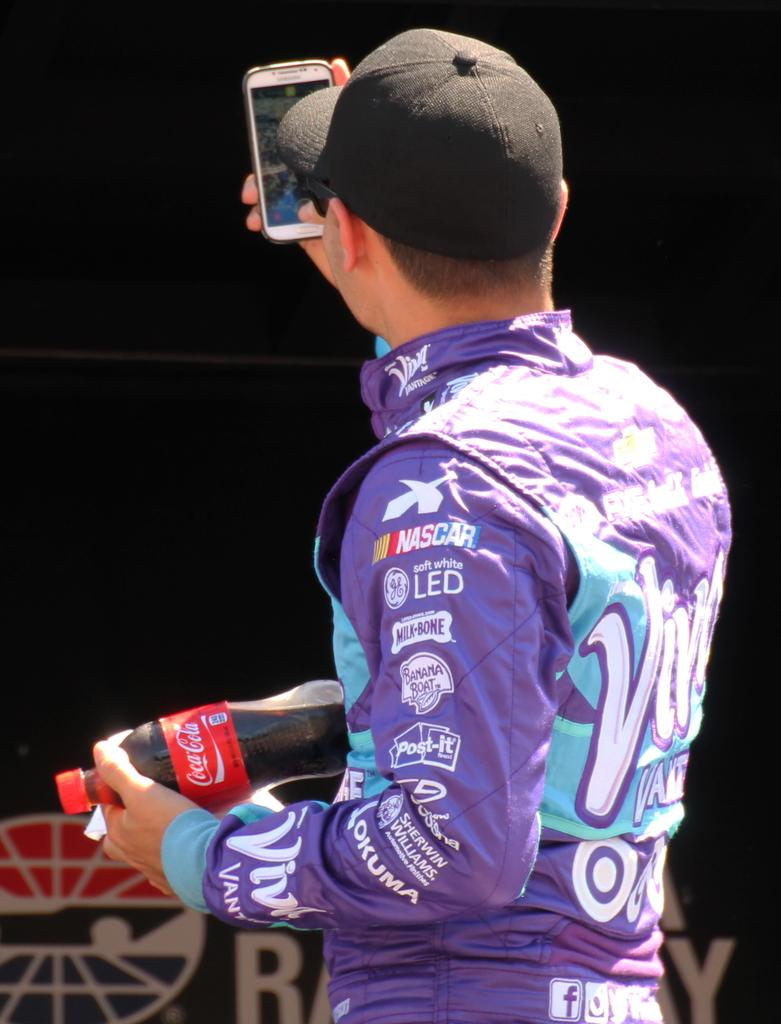<image>
Describe the image concisely. A man taking a picture wearing a purple jersey with nascar on it 